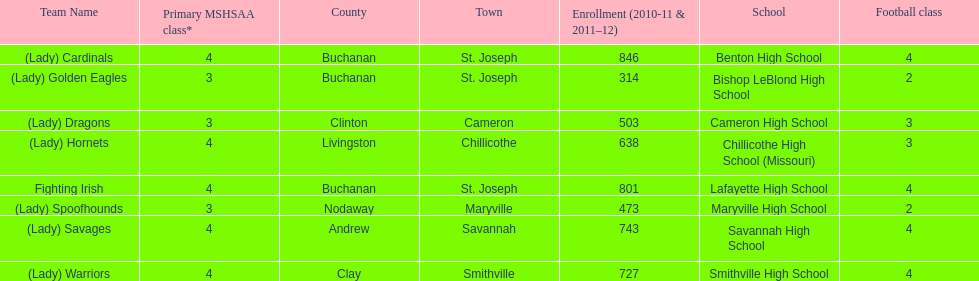What school has 3 football classes but only has 638 student enrollment? Chillicothe High School (Missouri). 